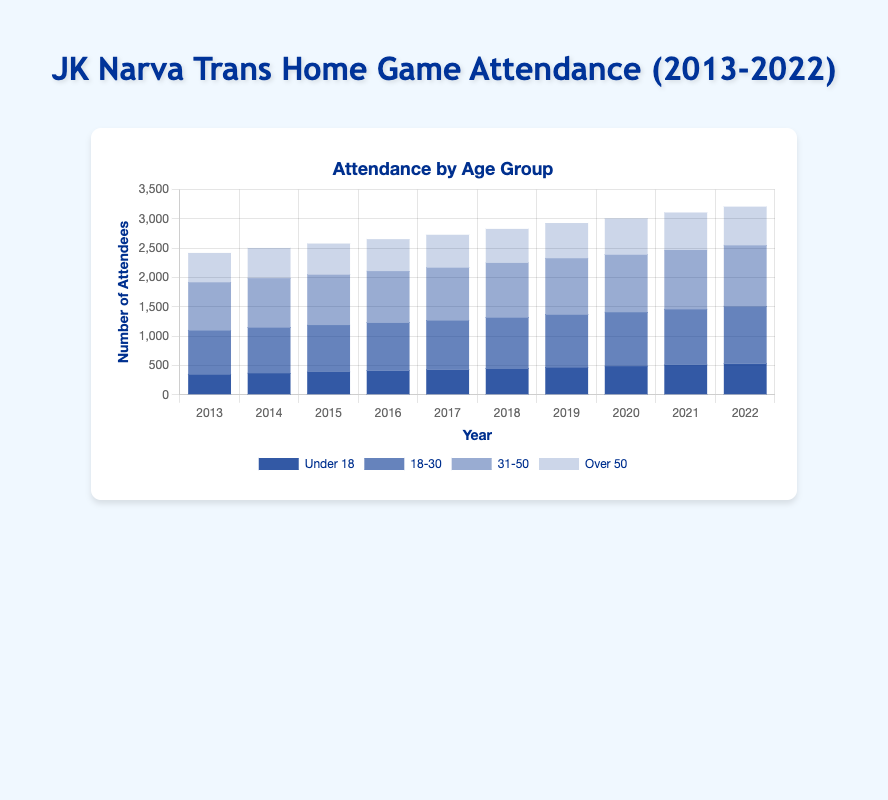How did the attendance for the under 18 group change from 2013 to 2022? In 2013, the attendance for the under 18 group was 350. In 2022, it increased to 530. To find the change: 530 - 350 = 180.
Answer: 180 Which age group had the highest attendance in 2022? In 2022, the bars represent attendance for each age group. The 31-50 age group had the tallest bar, indicating the highest attendance at 1040.
Answer: 31-50 By how much did the attendance of the 18-30 age group increase from 2013 to 2022? In 2013, the attendance for the 18-30 age group was 750. By 2022, it was 980. The increase is calculated as 980 - 750 = 230.
Answer: 230 What is the average attendance for the 31-50 age group over the 10 years? Sum the attendance for the 31-50 age group across all years and divide by 10. (820 + 840 + 860 + 880 + 900 + 930 + 960 + 980 + 1010 + 1040) / 10 = 9120 / 10 = 912.
Answer: 912 Which year had the highest combined attendance across all age groups? Compare the total bar height for each year. The highest combined attendance occurs in 2022, with the sum of 530 (under 18) + 980 (18-30) + 1040 (31-50) + 660 (over 50) = 3210.
Answer: 2022 Did any age group see a decrease in attendance over the 10 years? Examine the trend for each age group. All age groups show steady increases in attendance each year from 2013 to 2022.
Answer: No Compare the attendance of the over 50 group in 2013 and 2022. In 2013, the over 50 group had an attendance of 500. In 2022, it was 660. By comparing the two values, 660 > 500.
Answer: 660 > 500 By how much did the total attendance of the 18-30 age group increase over 10 years? Sum the annual increases from 2013 to 2022. Incremental increases are: 780-750, 800-780, 820-800, 840-820, 870-840, 900-870, 920-900, 950-920, 980-950. The total increase is 30 + 20 + 20 + 20 + 30 + 30 + 20 + 30 + 30 = 230.
Answer: 230 Which two age groups experienced the highest total combined attendance in any year? Identify the year and age groups with the highest combined total. In 2022, the 31-50 age group had 1040 and the 18-30 age group had 980, totaling 2020.
Answer: 31-50 and 18-30 in 2022 